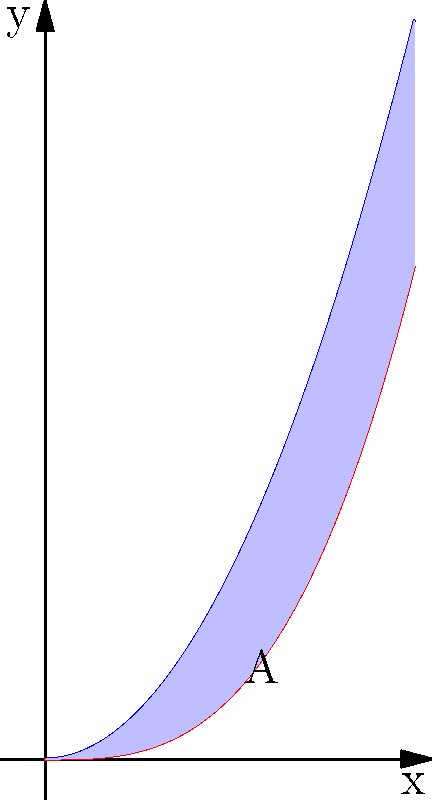In a recent sports analytics project, you're studying the trajectory of a football thrown by George Addo Jr.'s favorite quarterback. The path of the ball can be modeled by two polynomial functions: $f(x) = x^2$ and $g(x) = \frac{x^3}{3}$, where $x$ represents the horizontal distance and $y$ represents the height. Calculate the area between these two curves from $x = 0$ to $x = 2$, which represents the region where the quarterback has the most control over the ball's path. To find the area between two curves, we need to follow these steps:

1) The area between the curves is given by the integral of the difference between the upper function and the lower function:

   $A = \int_a^b [f(x) - g(x)] dx$

   where $f(x)$ is the upper function and $g(x)$ is the lower function.

2) In this case, $f(x) = x^2$ and $g(x) = \frac{x^3}{3}$, and we're integrating from $x = 0$ to $x = 2$.

3) Set up the integral:

   $A = \int_0^2 [x^2 - \frac{x^3}{3}] dx$

4) Integrate the expression:

   $A = [\frac{x^3}{3} - \frac{x^4}{12}]_0^2$

5) Evaluate the integral at the upper and lower bounds:

   $A = (\frac{8}{3} - \frac{16}{12}) - (0 - 0)$

6) Simplify:

   $A = \frac{8}{3} - \frac{4}{3} = \frac{4}{3}$

Therefore, the area between the curves from $x = 0$ to $x = 2$ is $\frac{4}{3}$ square units.
Answer: $\frac{4}{3}$ square units 